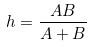Convert formula to latex. <formula><loc_0><loc_0><loc_500><loc_500>h = \frac { A B } { A + B }</formula> 